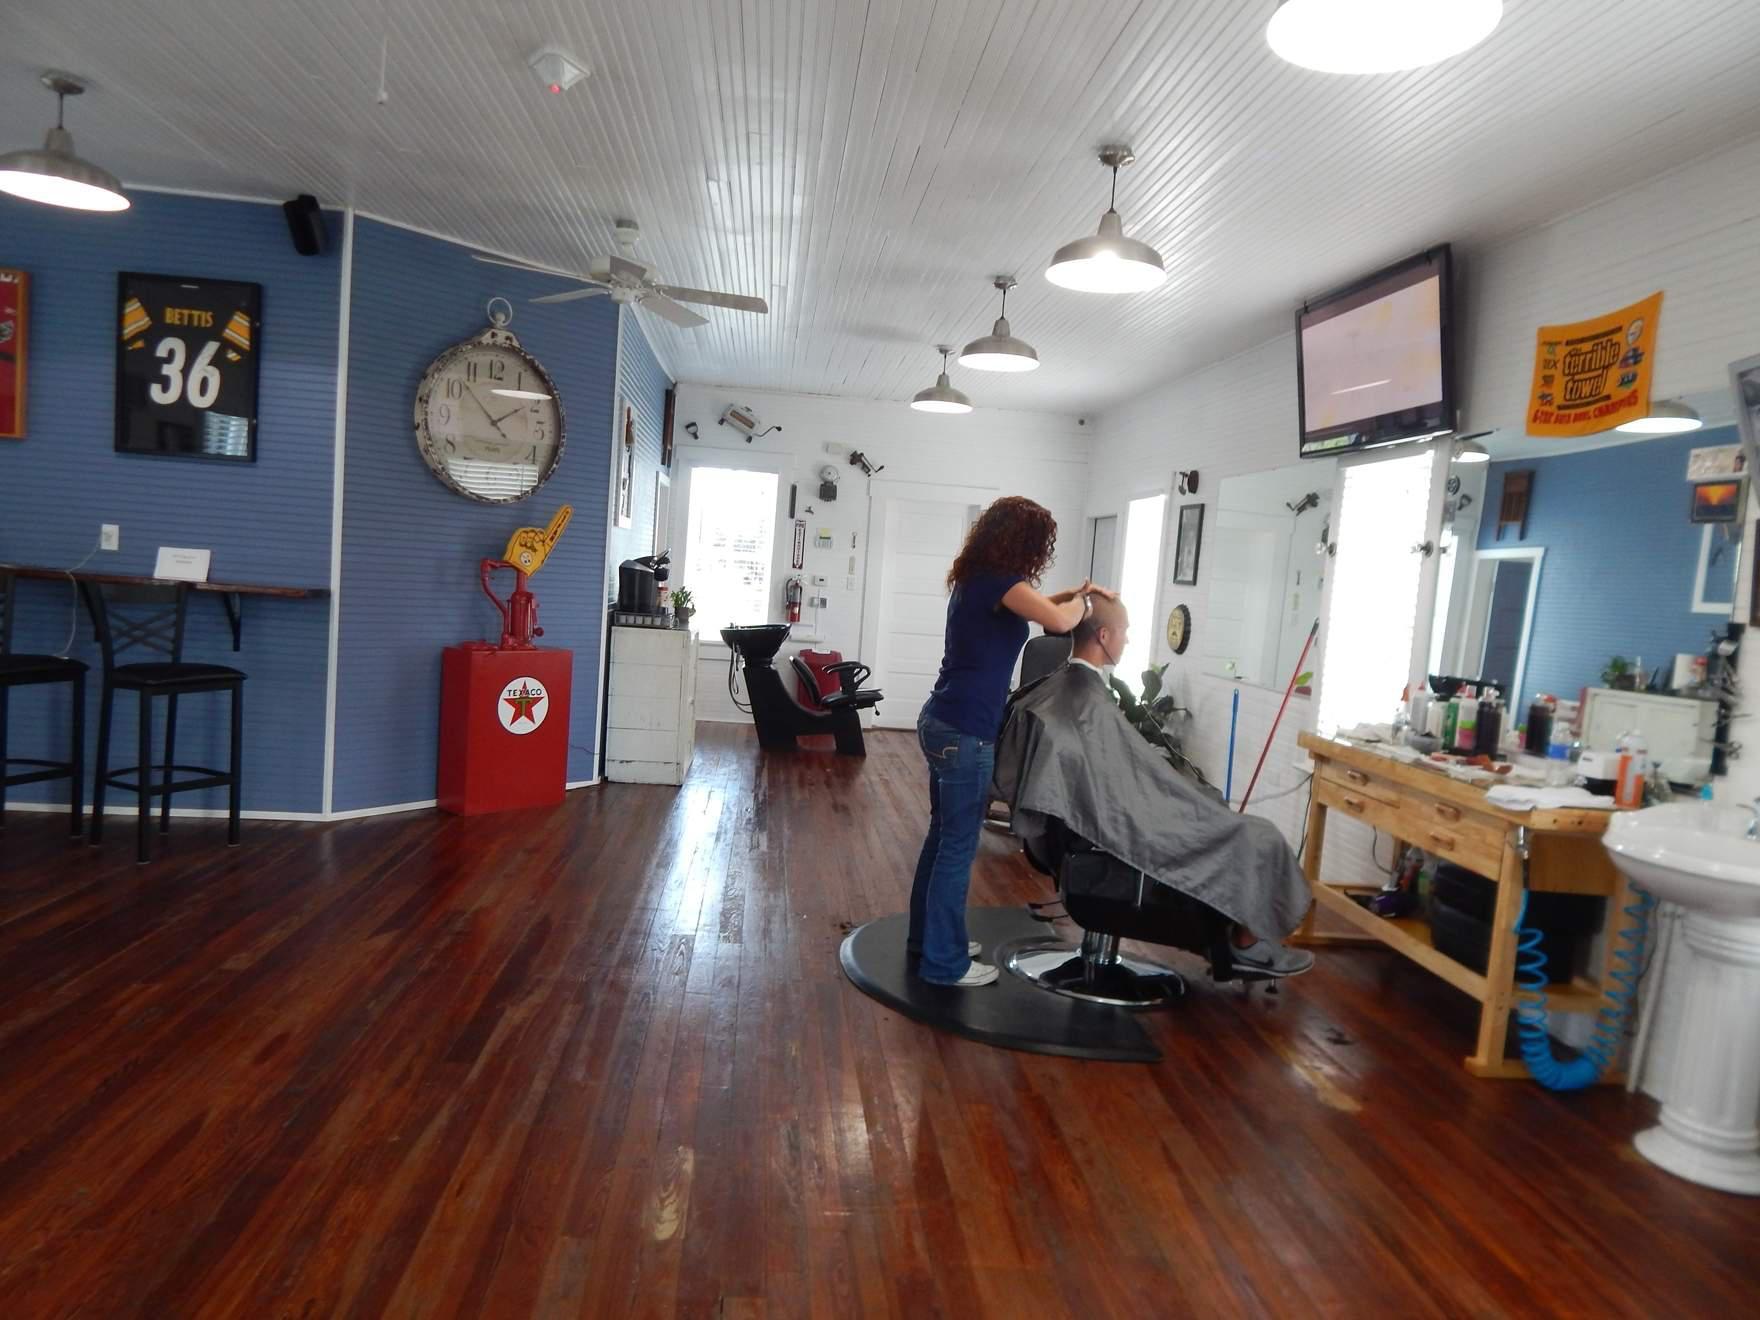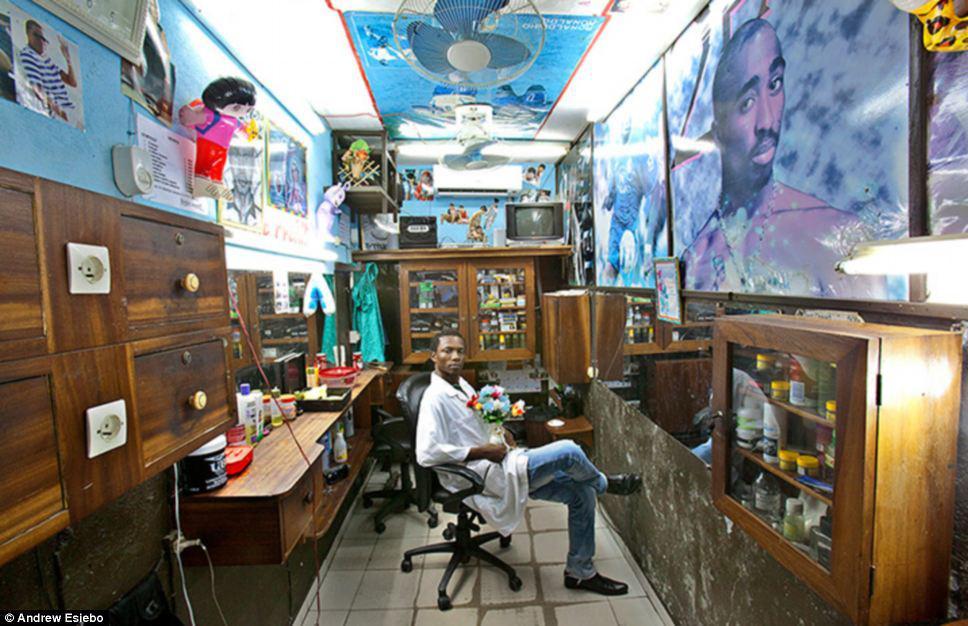The first image is the image on the left, the second image is the image on the right. Given the left and right images, does the statement "There are people in both images." hold true? Answer yes or no. Yes. The first image is the image on the left, the second image is the image on the right. For the images displayed, is the sentence "There is a total of three people in the barber shop." factually correct? Answer yes or no. Yes. 